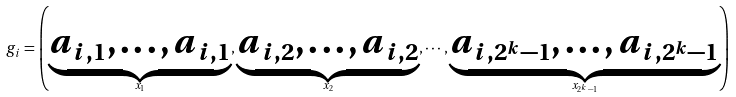<formula> <loc_0><loc_0><loc_500><loc_500>g _ { i } = \left ( \underbrace { a _ { i , 1 } , \dots , a _ { i , 1 } } _ { x _ { 1 } } , \underbrace { a _ { i , 2 } , \dots , a _ { i , 2 } } _ { x _ { 2 } } , \cdots , \underbrace { a _ { i , 2 ^ { k } - 1 } , \dots , a _ { i , 2 ^ { k } - 1 } } _ { x _ { 2 ^ { k } - 1 } } \right )</formula> 